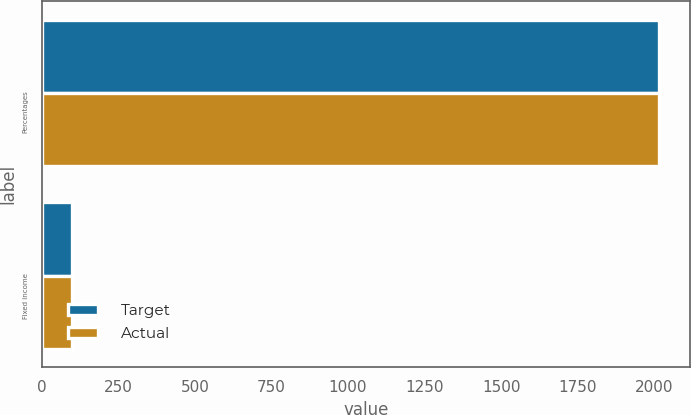Convert chart to OTSL. <chart><loc_0><loc_0><loc_500><loc_500><stacked_bar_chart><ecel><fcel>Percentages<fcel>Fixed income<nl><fcel>Target<fcel>2017<fcel>99<nl><fcel>Actual<fcel>2017<fcel>100<nl></chart> 